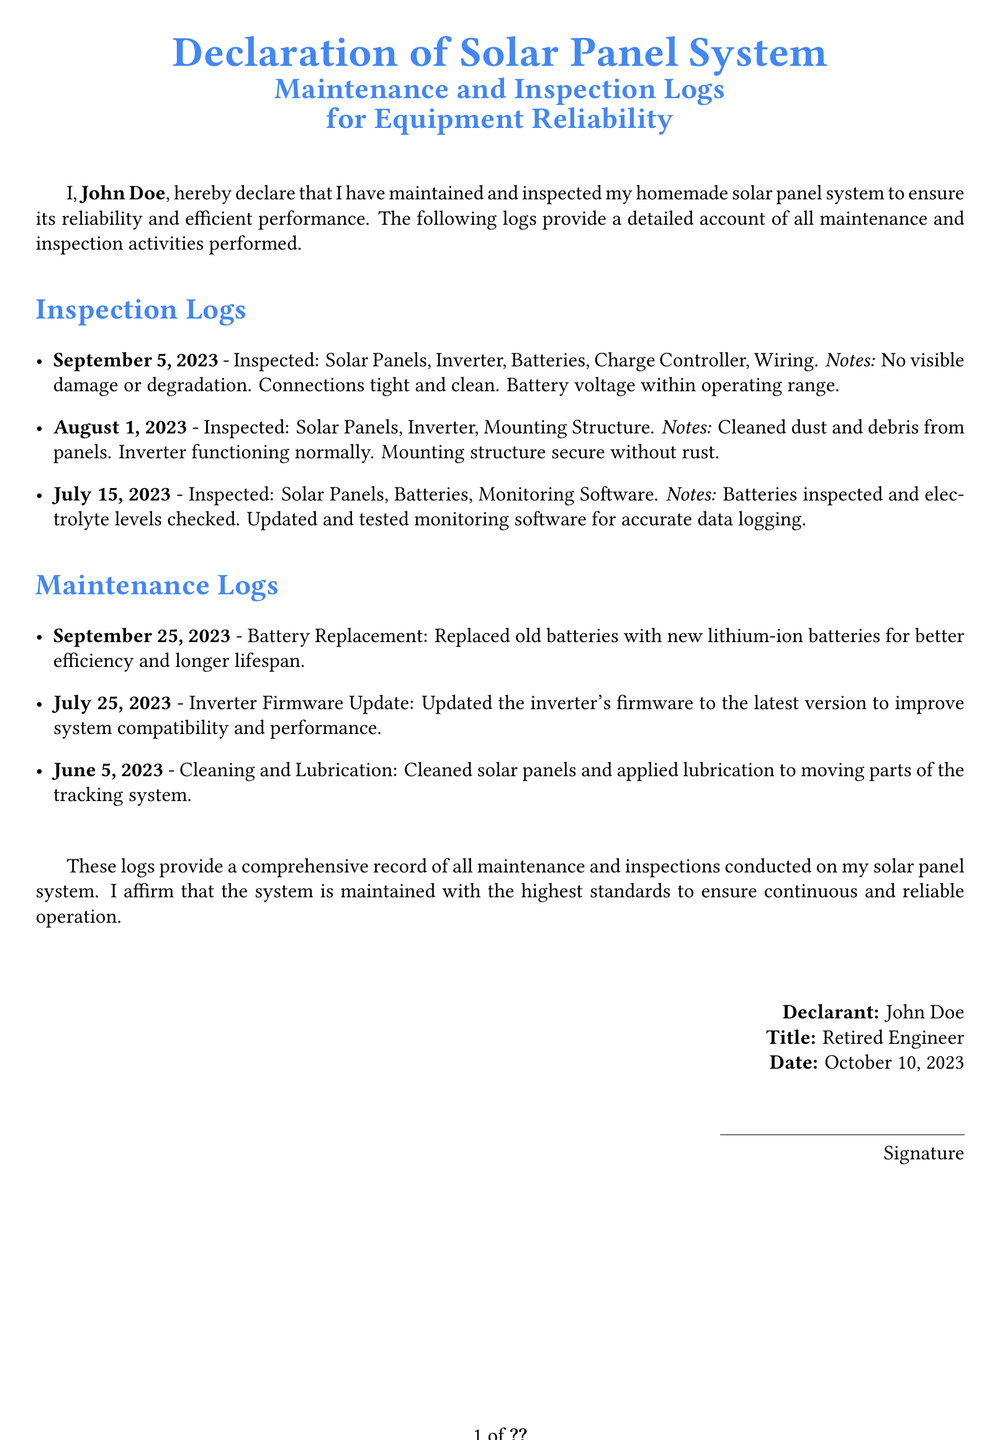What is the name of the declarant? The declarant's name is stated at the beginning of the document, which is John Doe.
Answer: John Doe What is the date of the declaration? The date of the declaration is mentioned at the bottom of the document.
Answer: October 10, 2023 What was inspected on September 5, 2023? The inspection log lists the items inspected on that date which include Solar Panels, Inverter, Batteries, Charge Controller, and Wiring.
Answer: Solar Panels, Inverter, Batteries, Charge Controller, Wiring How many maintenance logs are provided? The document includes specific entries for maintenance, which can be counted.
Answer: Three What type of batteries were replaced on September 25, 2023? The document specifies the type of batteries that were installed during maintenance.
Answer: Lithium-ion batteries What improvement was made to the inverter? The document mentions an action taken to enhance the performance of the inverter.
Answer: Firmware Update What activity was performed on June 5, 2023? The maintenance log for that date describes a particular type of activity carried out.
Answer: Cleaning and Lubrication What is emphasized about the maintenance standards? The declaration asserts a commitment to ensuring a particular quality level in system maintenance.
Answer: Highest standards 